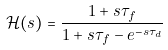<formula> <loc_0><loc_0><loc_500><loc_500>\mathcal { H } ( s ) & = \frac { 1 + s \tau _ { f } } { 1 + s \tau _ { f } - e ^ { - s \tau _ { d } } }</formula> 